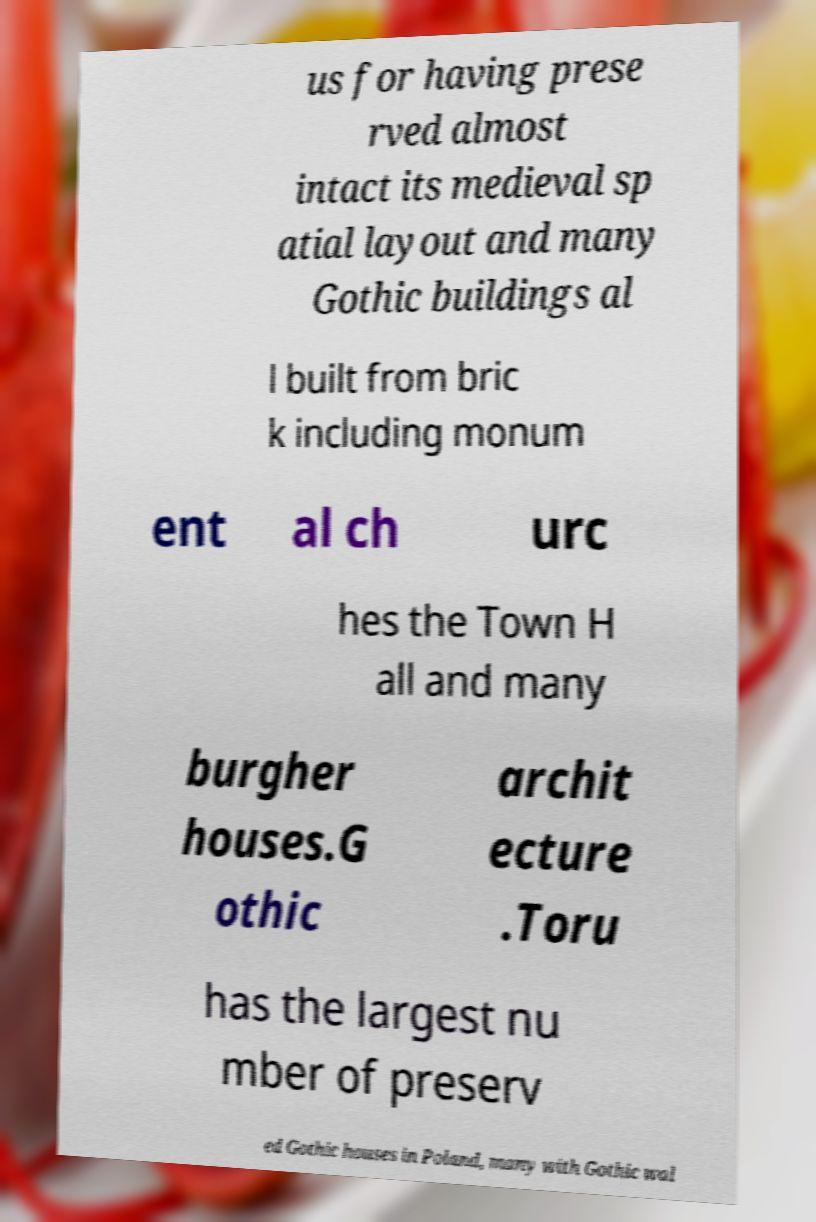What messages or text are displayed in this image? I need them in a readable, typed format. us for having prese rved almost intact its medieval sp atial layout and many Gothic buildings al l built from bric k including monum ent al ch urc hes the Town H all and many burgher houses.G othic archit ecture .Toru has the largest nu mber of preserv ed Gothic houses in Poland, many with Gothic wal 